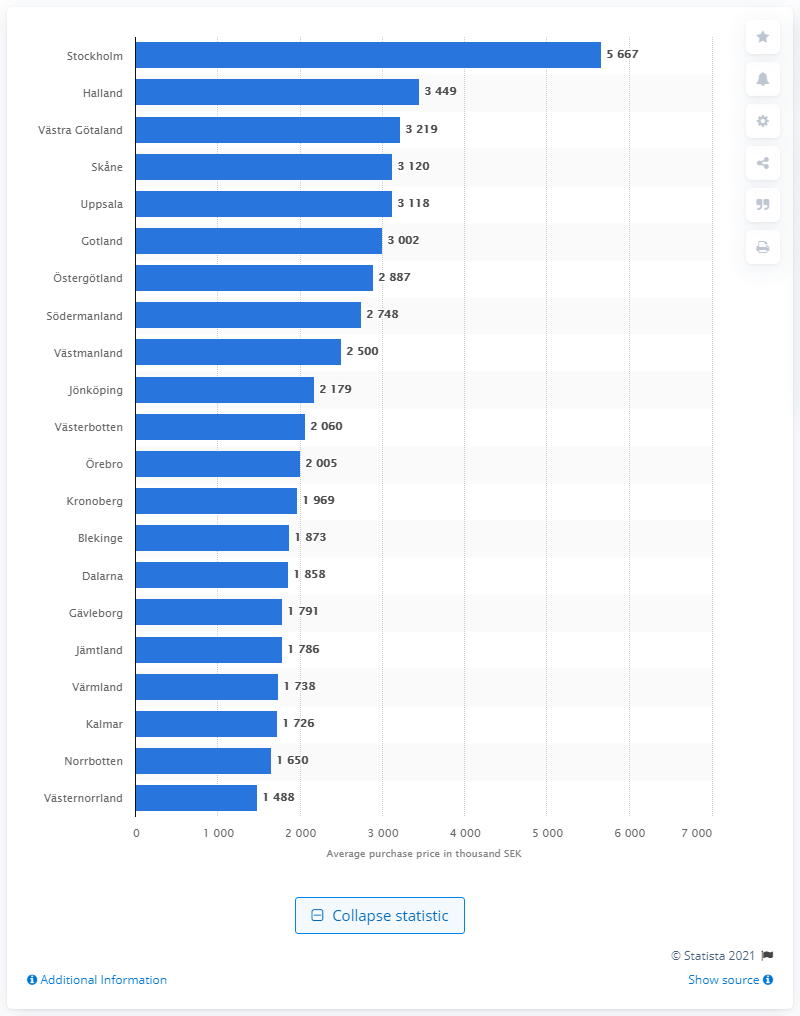Give some essential details in this illustration. In 2019, the highest average purchase price for one- and two-residential properties was in Stockholm, Sweden. 